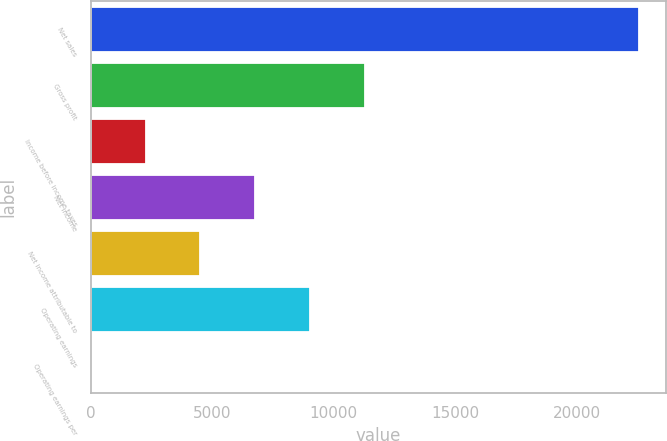Convert chart to OTSL. <chart><loc_0><loc_0><loc_500><loc_500><bar_chart><fcel>Net sales<fcel>Gross profit<fcel>Income before income taxes<fcel>Net income<fcel>Net income attributable to<fcel>Operating earnings<fcel>Operating earnings per<nl><fcel>22552<fcel>11278<fcel>2258.77<fcel>6768.37<fcel>4513.57<fcel>9023.17<fcel>3.97<nl></chart> 